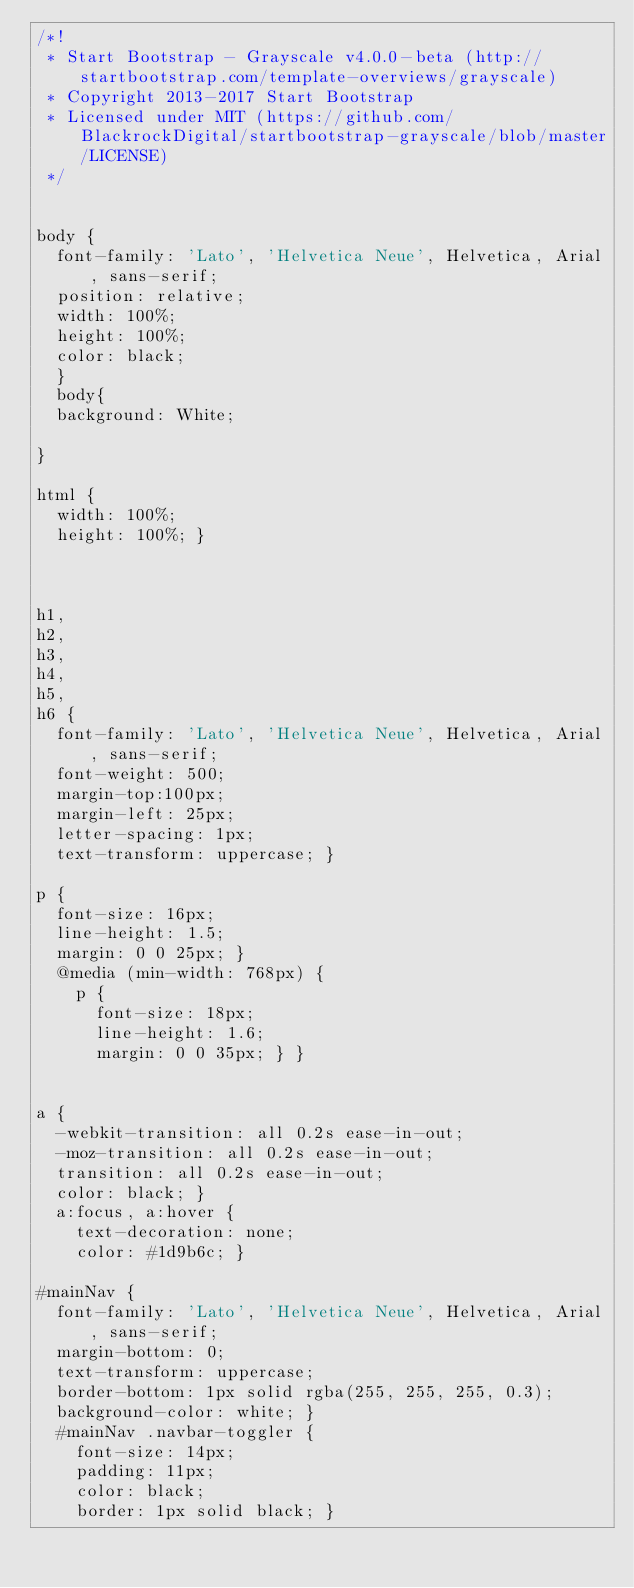<code> <loc_0><loc_0><loc_500><loc_500><_CSS_>/*!
 * Start Bootstrap - Grayscale v4.0.0-beta (http://startbootstrap.com/template-overviews/grayscale)
 * Copyright 2013-2017 Start Bootstrap
 * Licensed under MIT (https://github.com/BlackrockDigital/startbootstrap-grayscale/blob/master/LICENSE)
 */


body {
  font-family: 'Lato', 'Helvetica Neue', Helvetica, Arial, sans-serif;
  position: relative;
  width: 100%;
  height: 100%;
  color: black;
  }
  body{
  background: White;
  
}

html {
  width: 100%;
  height: 100%; }



h1,
h2,
h3,
h4,
h5,
h6 {
  font-family: 'Lato', 'Helvetica Neue', Helvetica, Arial, sans-serif;
  font-weight: 500;
  margin-top:100px;
  margin-left: 25px;
  letter-spacing: 1px;
  text-transform: uppercase; }

p {
  font-size: 16px;
  line-height: 1.5;
  margin: 0 0 25px; }
  @media (min-width: 768px) {
    p {
      font-size: 18px;
      line-height: 1.6;
      margin: 0 0 35px; } }

 
a {
  -webkit-transition: all 0.2s ease-in-out;
  -moz-transition: all 0.2s ease-in-out;
  transition: all 0.2s ease-in-out;
  color: black; }
  a:focus, a:hover {
    text-decoration: none;
    color: #1d9b6c; }

#mainNav {
  font-family: 'Lato', 'Helvetica Neue', Helvetica, Arial, sans-serif;
  margin-bottom: 0;
  text-transform: uppercase;
  border-bottom: 1px solid rgba(255, 255, 255, 0.3);
  background-color: white; }
  #mainNav .navbar-toggler {
    font-size: 14px;
    padding: 11px;
    color: black;
    border: 1px solid black; }</code> 